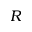<formula> <loc_0><loc_0><loc_500><loc_500>R</formula> 